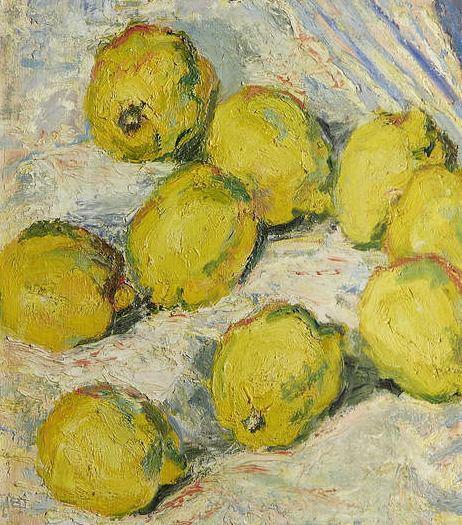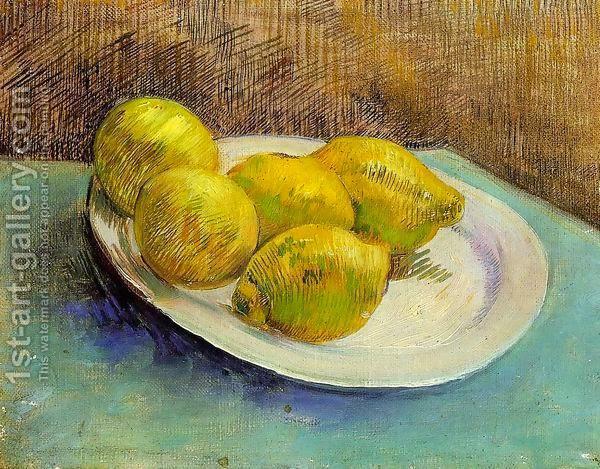The first image is the image on the left, the second image is the image on the right. Evaluate the accuracy of this statement regarding the images: "The fruit is sliced into quarters or smaller.". Is it true? Answer yes or no. No. The first image is the image on the left, the second image is the image on the right. Assess this claim about the two images: "The artwork of one image shows three whole lemons arranged in a bowl, while a second artwork image is of lemon wedges in blue shadows.". Correct or not? Answer yes or no. No. 